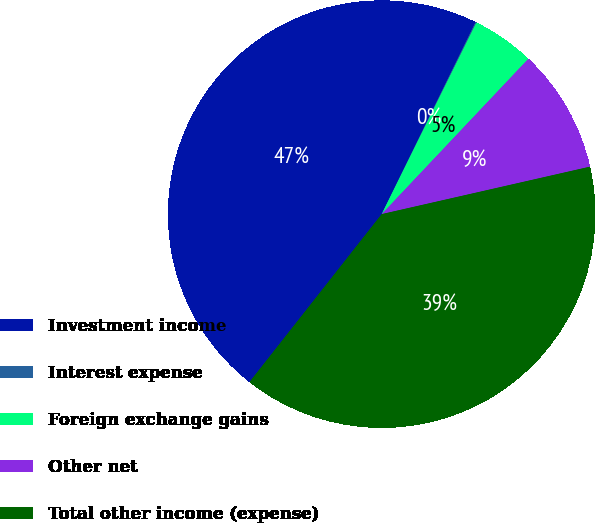<chart> <loc_0><loc_0><loc_500><loc_500><pie_chart><fcel>Investment income<fcel>Interest expense<fcel>Foreign exchange gains<fcel>Other net<fcel>Total other income (expense)<nl><fcel>46.62%<fcel>0.08%<fcel>4.73%<fcel>9.39%<fcel>39.18%<nl></chart> 